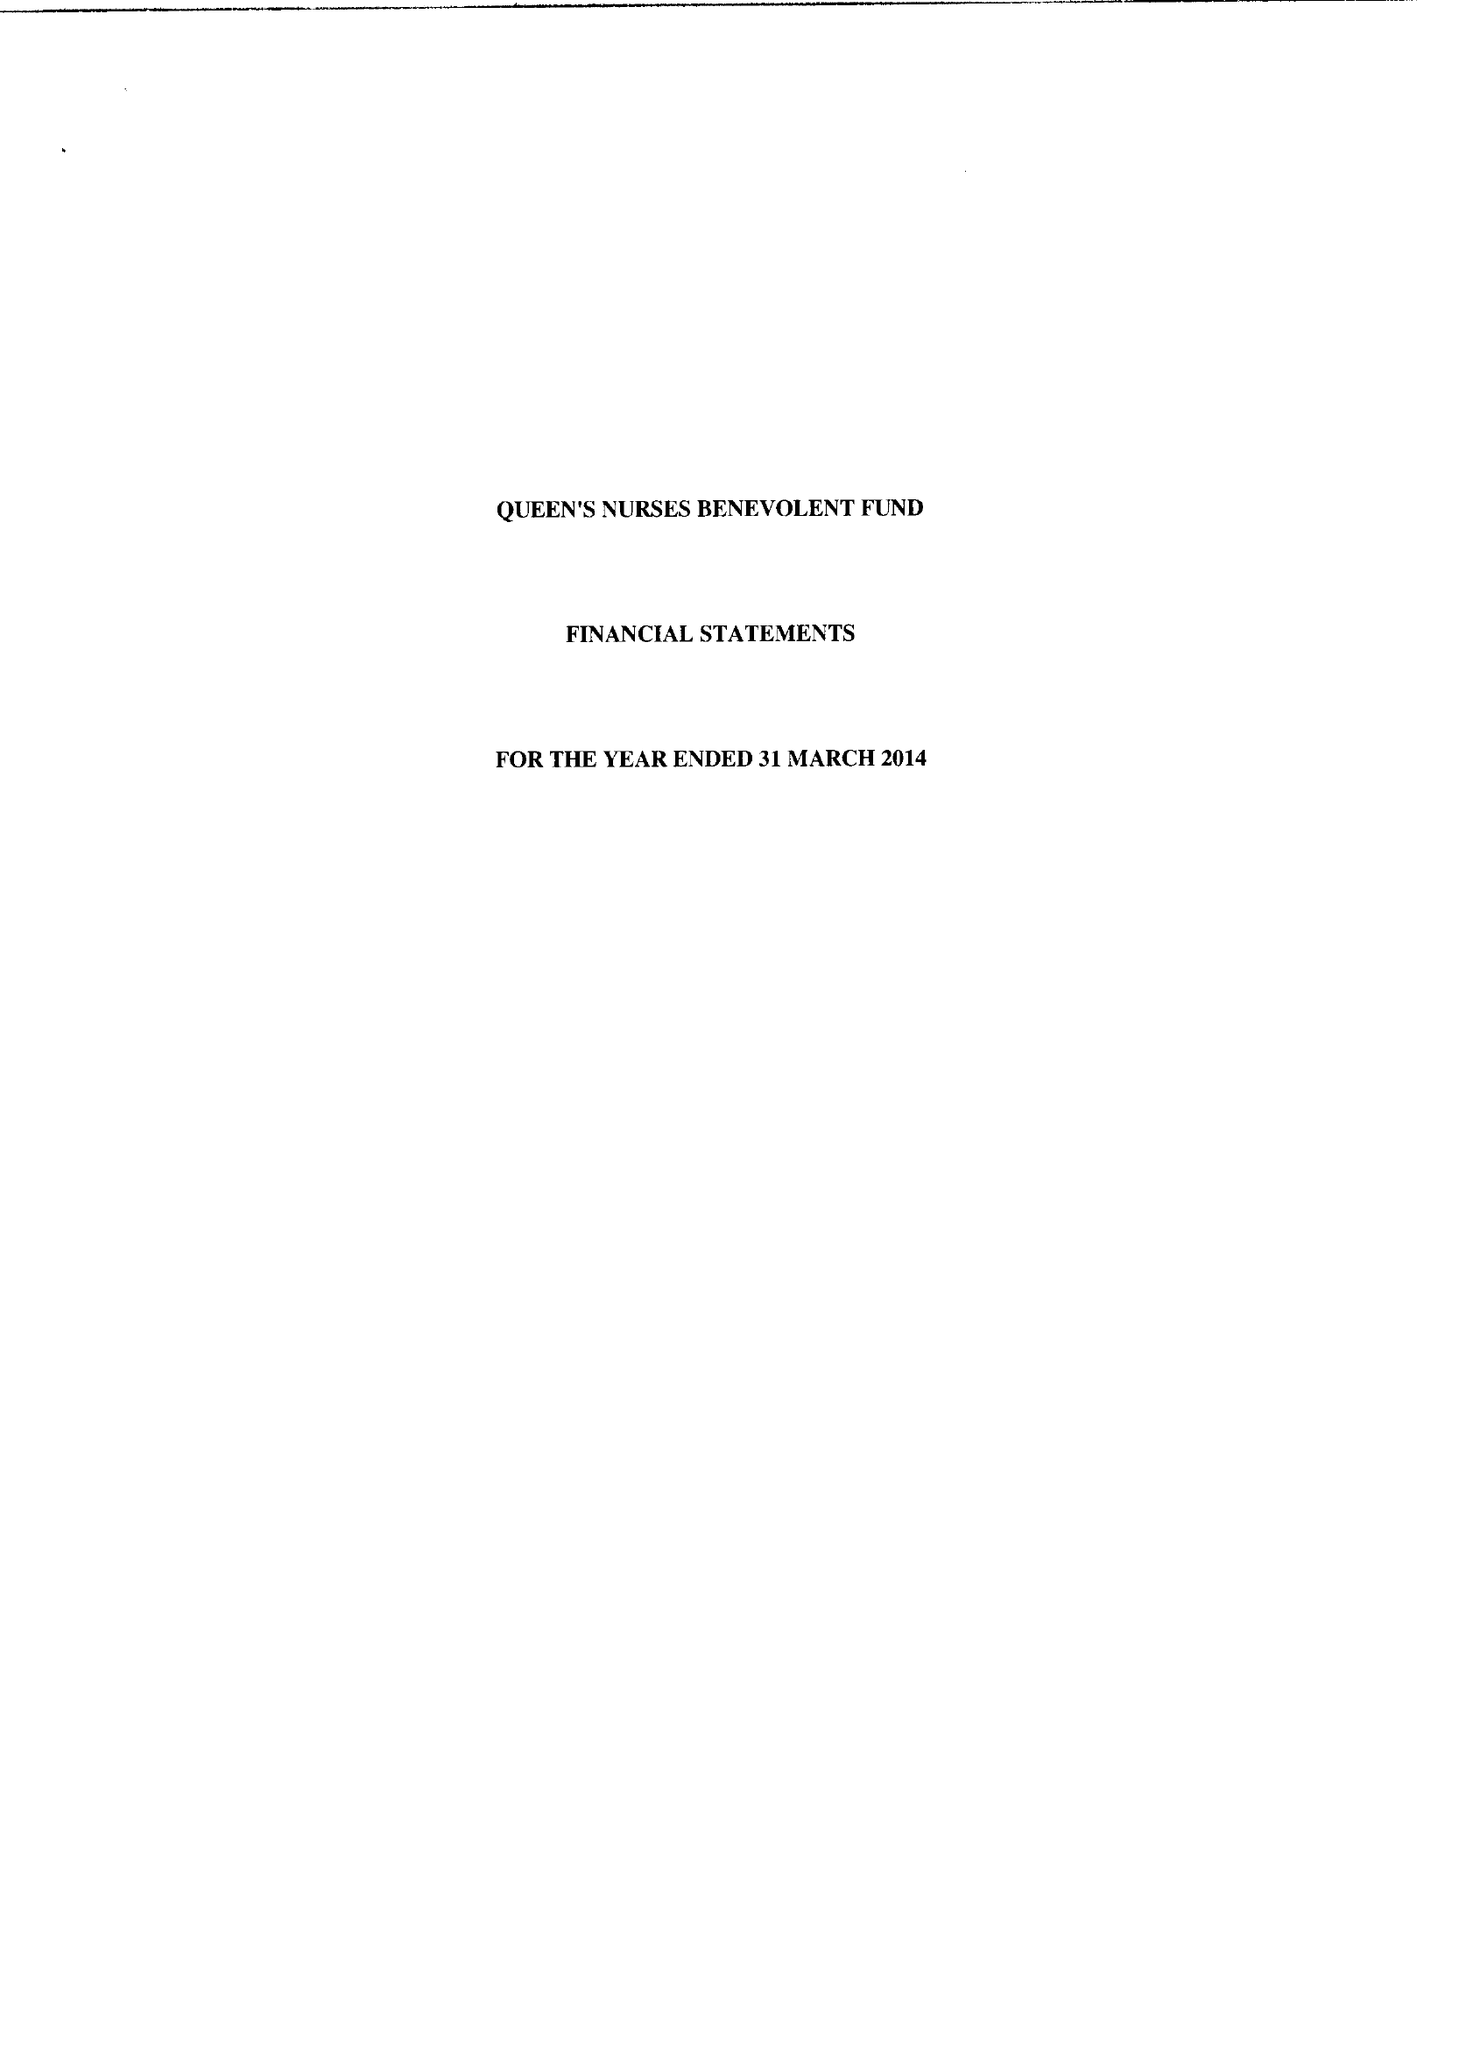What is the value for the report_date?
Answer the question using a single word or phrase. 2014-03-31 